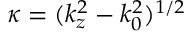Convert formula to latex. <formula><loc_0><loc_0><loc_500><loc_500>\kappa = ( k _ { z } ^ { 2 } - k _ { 0 } ^ { 2 } ) ^ { 1 / 2 }</formula> 